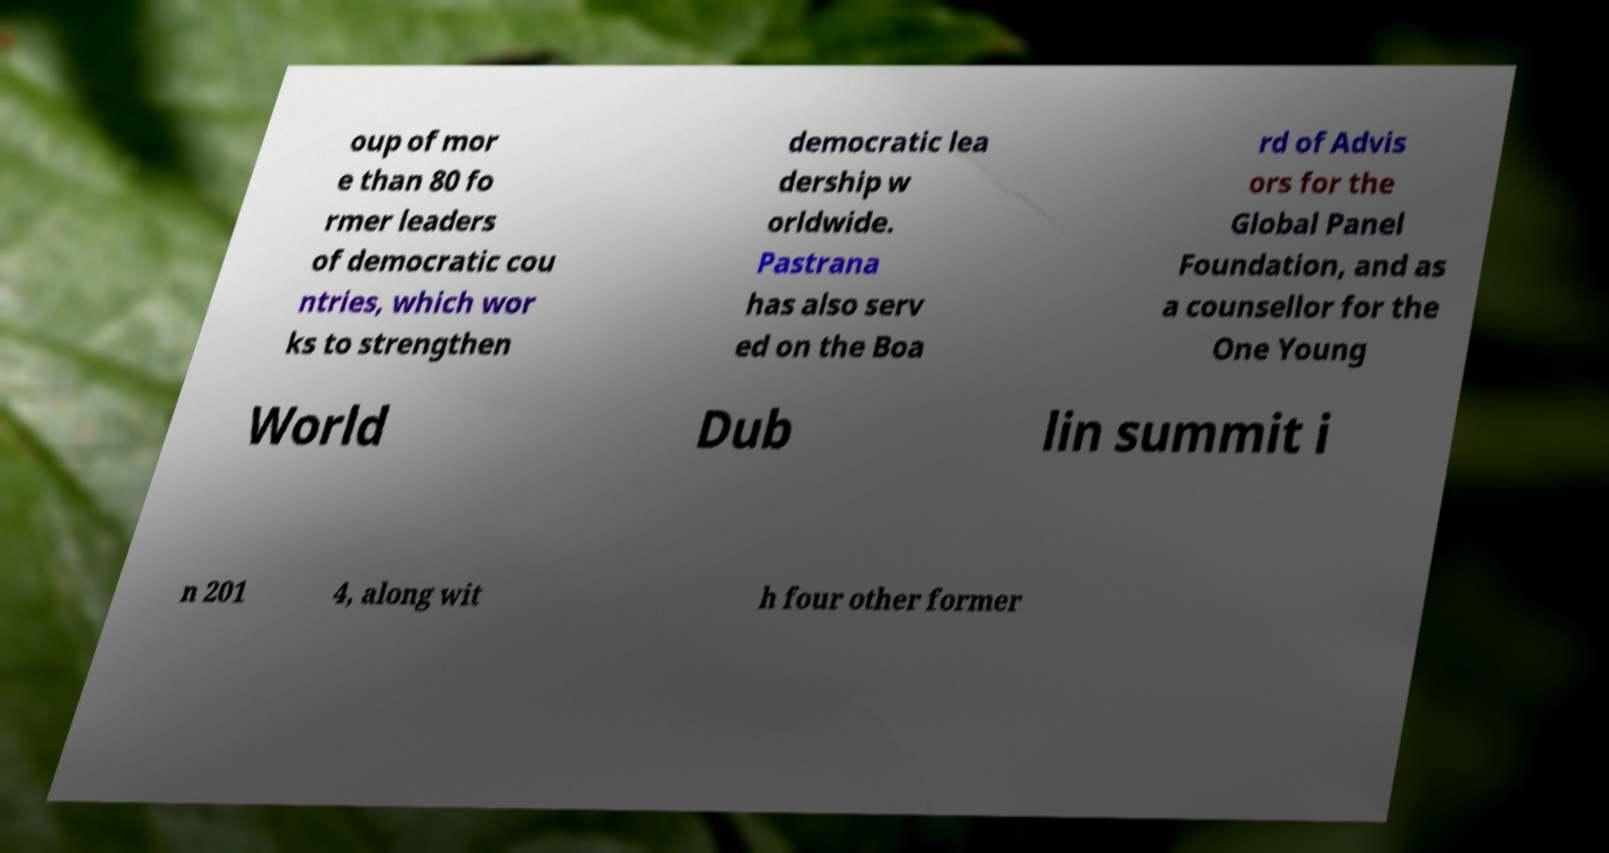Please identify and transcribe the text found in this image. oup of mor e than 80 fo rmer leaders of democratic cou ntries, which wor ks to strengthen democratic lea dership w orldwide. Pastrana has also serv ed on the Boa rd of Advis ors for the Global Panel Foundation, and as a counsellor for the One Young World Dub lin summit i n 201 4, along wit h four other former 